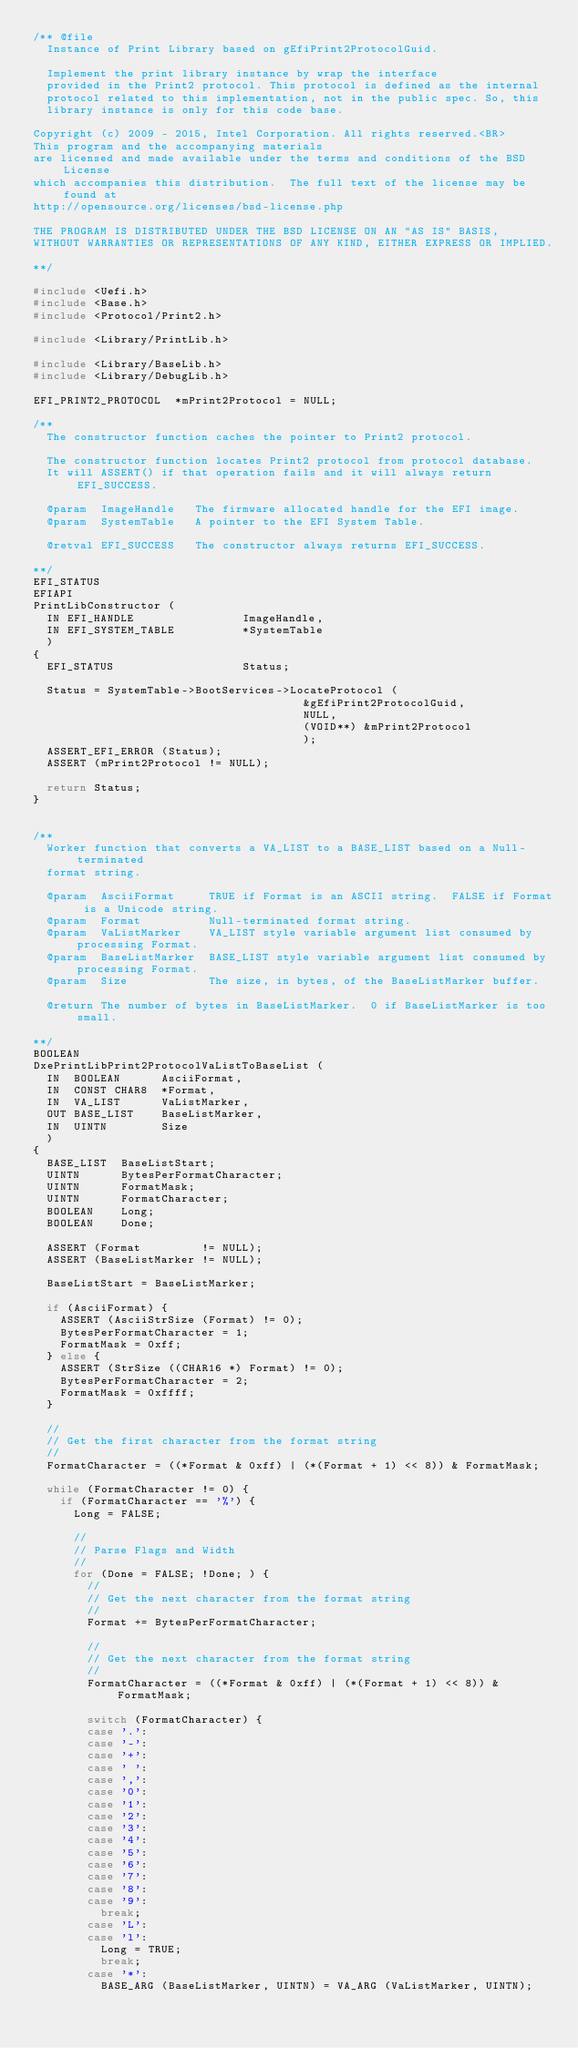Convert code to text. <code><loc_0><loc_0><loc_500><loc_500><_C_>/** @file
  Instance of Print Library based on gEfiPrint2ProtocolGuid.

  Implement the print library instance by wrap the interface
  provided in the Print2 protocol. This protocol is defined as the internal
  protocol related to this implementation, not in the public spec. So, this
  library instance is only for this code base.

Copyright (c) 2009 - 2015, Intel Corporation. All rights reserved.<BR>
This program and the accompanying materials
are licensed and made available under the terms and conditions of the BSD License
which accompanies this distribution.  The full text of the license may be found at
http://opensource.org/licenses/bsd-license.php

THE PROGRAM IS DISTRIBUTED UNDER THE BSD LICENSE ON AN "AS IS" BASIS,
WITHOUT WARRANTIES OR REPRESENTATIONS OF ANY KIND, EITHER EXPRESS OR IMPLIED.

**/

#include <Uefi.h>
#include <Base.h>
#include <Protocol/Print2.h>

#include <Library/PrintLib.h>

#include <Library/BaseLib.h>
#include <Library/DebugLib.h>

EFI_PRINT2_PROTOCOL  *mPrint2Protocol = NULL;

/**
  The constructor function caches the pointer to Print2 protocol.

  The constructor function locates Print2 protocol from protocol database.
  It will ASSERT() if that operation fails and it will always return EFI_SUCCESS.

  @param  ImageHandle   The firmware allocated handle for the EFI image.
  @param  SystemTable   A pointer to the EFI System Table.

  @retval EFI_SUCCESS   The constructor always returns EFI_SUCCESS.

**/
EFI_STATUS
EFIAPI
PrintLibConstructor (
  IN EFI_HANDLE                ImageHandle,
  IN EFI_SYSTEM_TABLE          *SystemTable
  )
{
  EFI_STATUS                   Status;

  Status = SystemTable->BootServices->LocateProtocol (
                                        &gEfiPrint2ProtocolGuid,
                                        NULL,
                                        (VOID**) &mPrint2Protocol
                                        );
  ASSERT_EFI_ERROR (Status);
  ASSERT (mPrint2Protocol != NULL);

  return Status;
}


/**
  Worker function that converts a VA_LIST to a BASE_LIST based on a Null-terminated
  format string.

  @param  AsciiFormat     TRUE if Format is an ASCII string.  FALSE if Format is a Unicode string.
  @param  Format          Null-terminated format string.
  @param  VaListMarker    VA_LIST style variable argument list consumed by processing Format.
  @param  BaseListMarker  BASE_LIST style variable argument list consumed by processing Format.
  @param  Size            The size, in bytes, of the BaseListMarker buffer.

  @return The number of bytes in BaseListMarker.  0 if BaseListMarker is too small.

**/
BOOLEAN
DxePrintLibPrint2ProtocolVaListToBaseList (
  IN  BOOLEAN      AsciiFormat,
  IN  CONST CHAR8  *Format,
  IN  VA_LIST      VaListMarker,
  OUT BASE_LIST    BaseListMarker,
  IN  UINTN        Size
  )
{
  BASE_LIST  BaseListStart;
  UINTN      BytesPerFormatCharacter;
  UINTN      FormatMask;
  UINTN      FormatCharacter;
  BOOLEAN    Long;
  BOOLEAN    Done;

  ASSERT (Format         != NULL);
  ASSERT (BaseListMarker != NULL);

  BaseListStart = BaseListMarker;

  if (AsciiFormat) {
    ASSERT (AsciiStrSize (Format) != 0);
    BytesPerFormatCharacter = 1;
    FormatMask = 0xff;
  } else {
    ASSERT (StrSize ((CHAR16 *) Format) != 0);
    BytesPerFormatCharacter = 2;
    FormatMask = 0xffff;
  }

  //
  // Get the first character from the format string
  //
  FormatCharacter = ((*Format & 0xff) | (*(Format + 1) << 8)) & FormatMask;

  while (FormatCharacter != 0) {
    if (FormatCharacter == '%') {
      Long = FALSE;

      //
      // Parse Flags and Width
      //
      for (Done = FALSE; !Done; ) {
        //
        // Get the next character from the format string
        //
        Format += BytesPerFormatCharacter;

        //
        // Get the next character from the format string
        //
        FormatCharacter = ((*Format & 0xff) | (*(Format + 1) << 8)) & FormatMask;

        switch (FormatCharacter) {
        case '.':
        case '-':
        case '+':
        case ' ':
        case ',':
        case '0':
        case '1':
        case '2':
        case '3':
        case '4':
        case '5':
        case '6':
        case '7':
        case '8':
        case '9':
          break;
        case 'L':
        case 'l':
          Long = TRUE;
          break;
        case '*':
          BASE_ARG (BaseListMarker, UINTN) = VA_ARG (VaListMarker, UINTN);</code> 